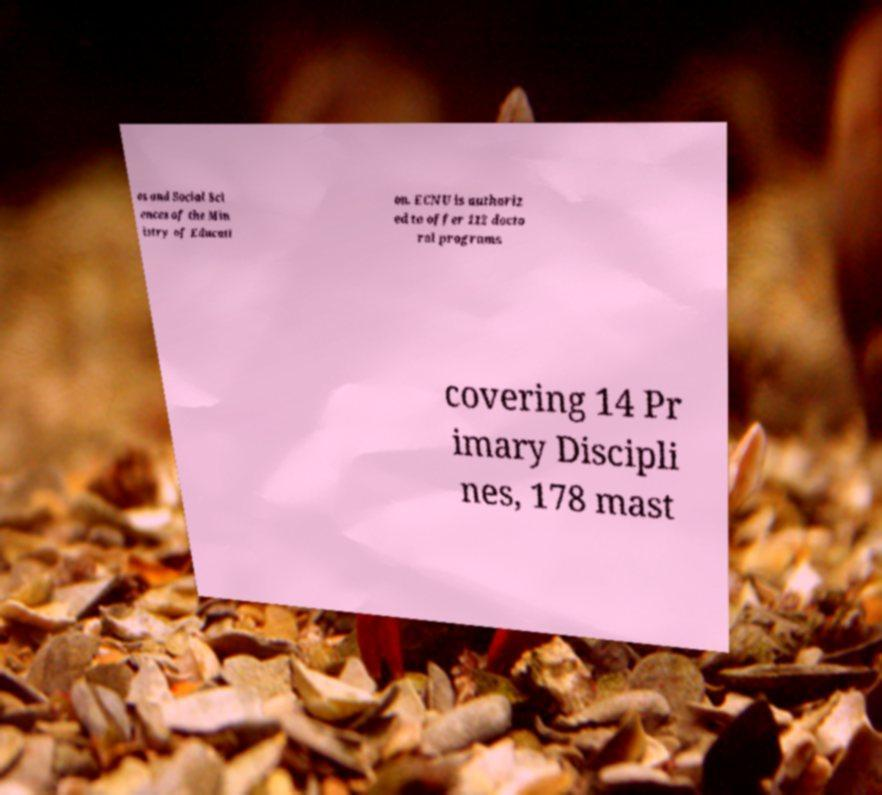Could you extract and type out the text from this image? es and Social Sci ences of the Min istry of Educati on. ECNU is authoriz ed to offer 112 docto ral programs covering 14 Pr imary Discipli nes, 178 mast 